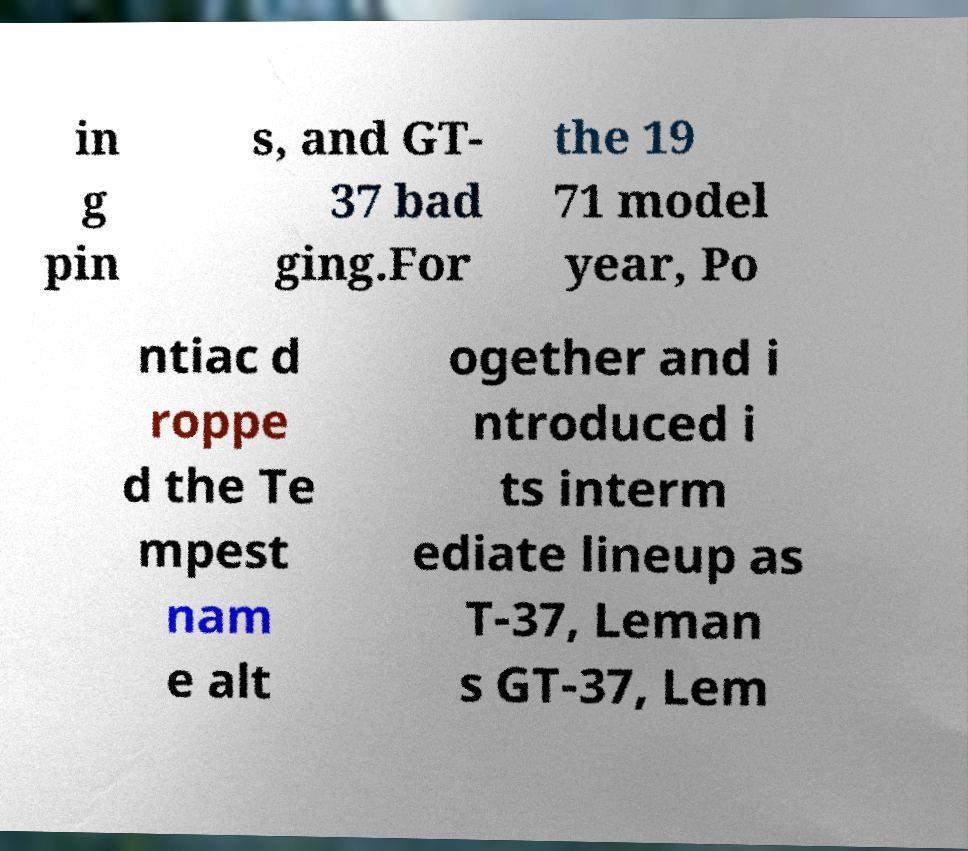For documentation purposes, I need the text within this image transcribed. Could you provide that? in g pin s, and GT- 37 bad ging.For the 19 71 model year, Po ntiac d roppe d the Te mpest nam e alt ogether and i ntroduced i ts interm ediate lineup as T-37, Leman s GT-37, Lem 